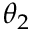Convert formula to latex. <formula><loc_0><loc_0><loc_500><loc_500>\theta _ { 2 }</formula> 